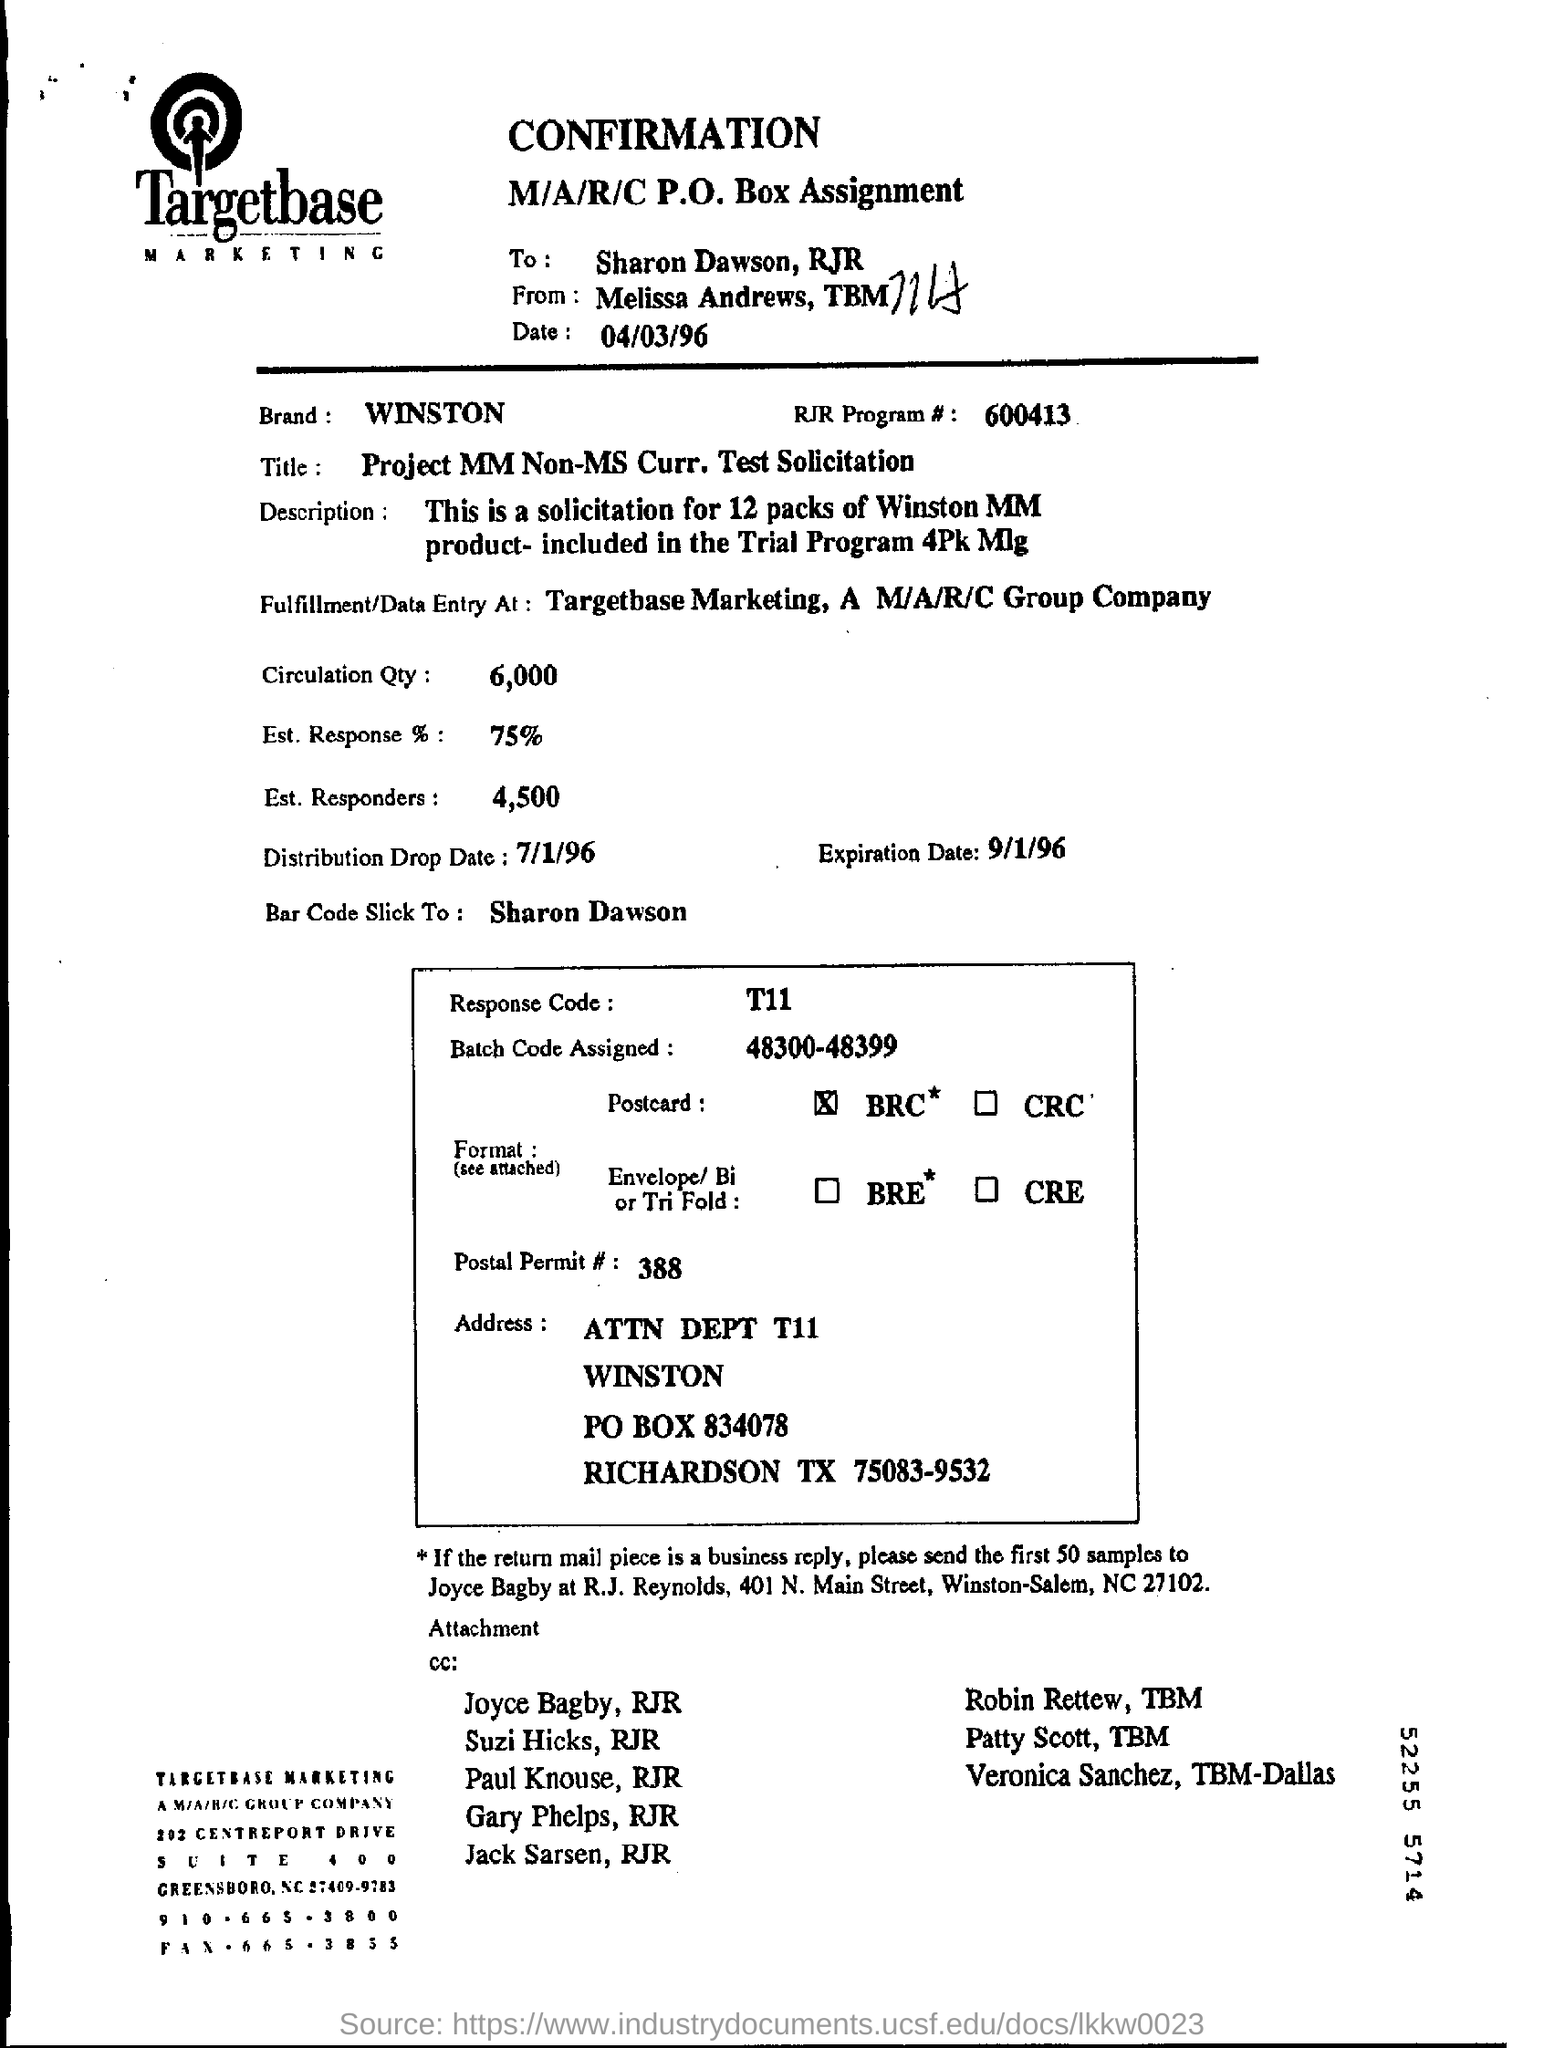List a handful of essential elements in this visual. The title of the paper that you mentioned is "Can you find out the title mentioned in this paper? project mm non-ms curr. test solicitation..". The circulation quantity mentioned in this document is 6000. Approximately 75% of the estimated response has been received. The circulation quantity, as listed in the form, is 6,000. WINSTON is the name mentioned as 'Brand.' 